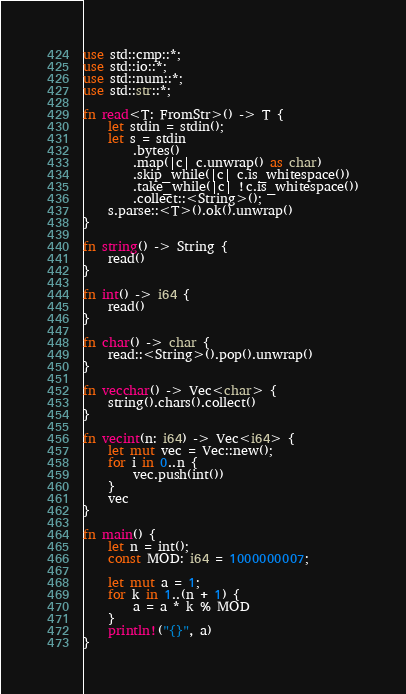<code> <loc_0><loc_0><loc_500><loc_500><_Rust_>use std::cmp::*;
use std::io::*;
use std::num::*;
use std::str::*;

fn read<T: FromStr>() -> T {
    let stdin = stdin();
    let s = stdin
        .bytes()
        .map(|c| c.unwrap() as char)
        .skip_while(|c| c.is_whitespace())
        .take_while(|c| !c.is_whitespace())
        .collect::<String>();
    s.parse::<T>().ok().unwrap()
}

fn string() -> String {
    read()
}

fn int() -> i64 {
    read()
}

fn char() -> char {
    read::<String>().pop().unwrap()
}

fn vecchar() -> Vec<char> {
    string().chars().collect()
}

fn vecint(n: i64) -> Vec<i64> {
    let mut vec = Vec::new();
    for i in 0..n {
        vec.push(int())
    }
    vec
}

fn main() {
    let n = int();
    const MOD: i64 = 1000000007;

    let mut a = 1;
    for k in 1..(n + 1) {
        a = a * k % MOD
    }
    println!("{}", a)
}
</code> 